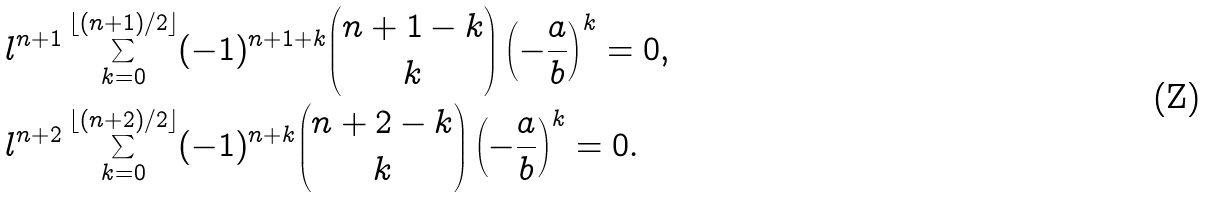Convert formula to latex. <formula><loc_0><loc_0><loc_500><loc_500>& l ^ { n + 1 } \sum _ { k = 0 } ^ { \lfloor ( n + 1 ) / 2 \rfloor } ( - 1 ) ^ { n + 1 + k } \binom { n + 1 - k } { k } \left ( - \frac { a } { b } \right ) ^ { k } = 0 , \\ & l ^ { n + 2 } \sum _ { k = 0 } ^ { \lfloor ( n + 2 ) / 2 \rfloor } ( - 1 ) ^ { n + k } \binom { n + 2 - k } { k } \left ( - \frac { a } { b } \right ) ^ { k } = 0 .</formula> 